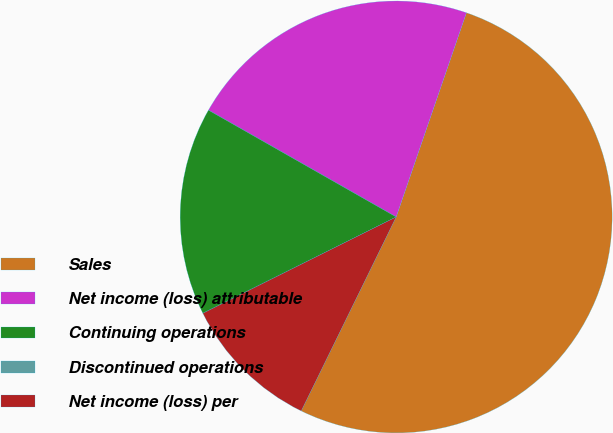<chart> <loc_0><loc_0><loc_500><loc_500><pie_chart><fcel>Sales<fcel>Net income (loss) attributable<fcel>Continuing operations<fcel>Discontinued operations<fcel>Net income (loss) per<nl><fcel>51.97%<fcel>22.04%<fcel>15.59%<fcel>0.0%<fcel>10.4%<nl></chart> 